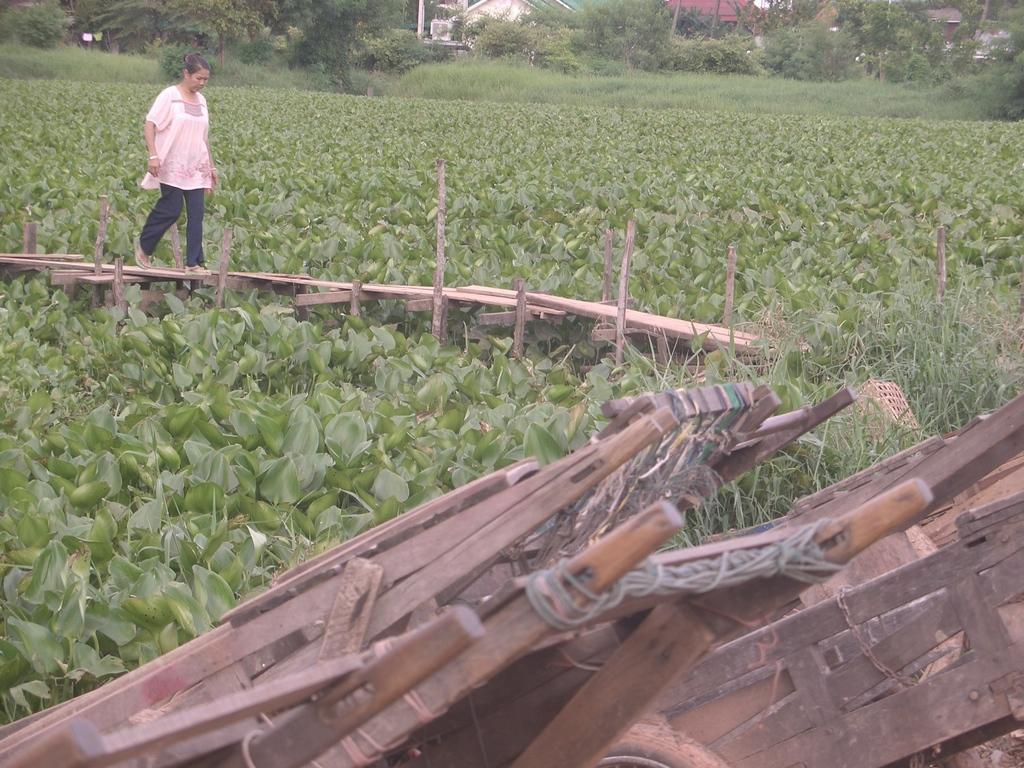Could you give a brief overview of what you see in this image? In this image we can see a lady walking on the wooden path, there are plants, trees, grass, also we can see houses, and some wooden objects. 